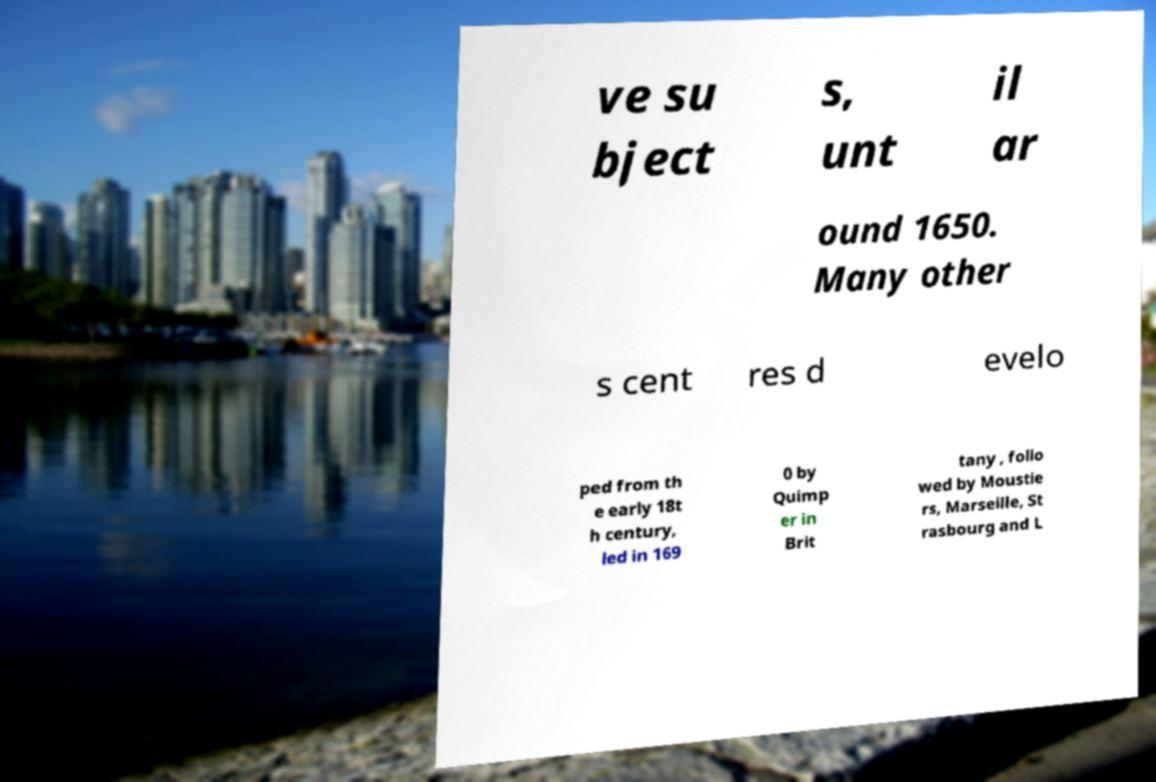Please identify and transcribe the text found in this image. ve su bject s, unt il ar ound 1650. Many other s cent res d evelo ped from th e early 18t h century, led in 169 0 by Quimp er in Brit tany , follo wed by Moustie rs, Marseille, St rasbourg and L 